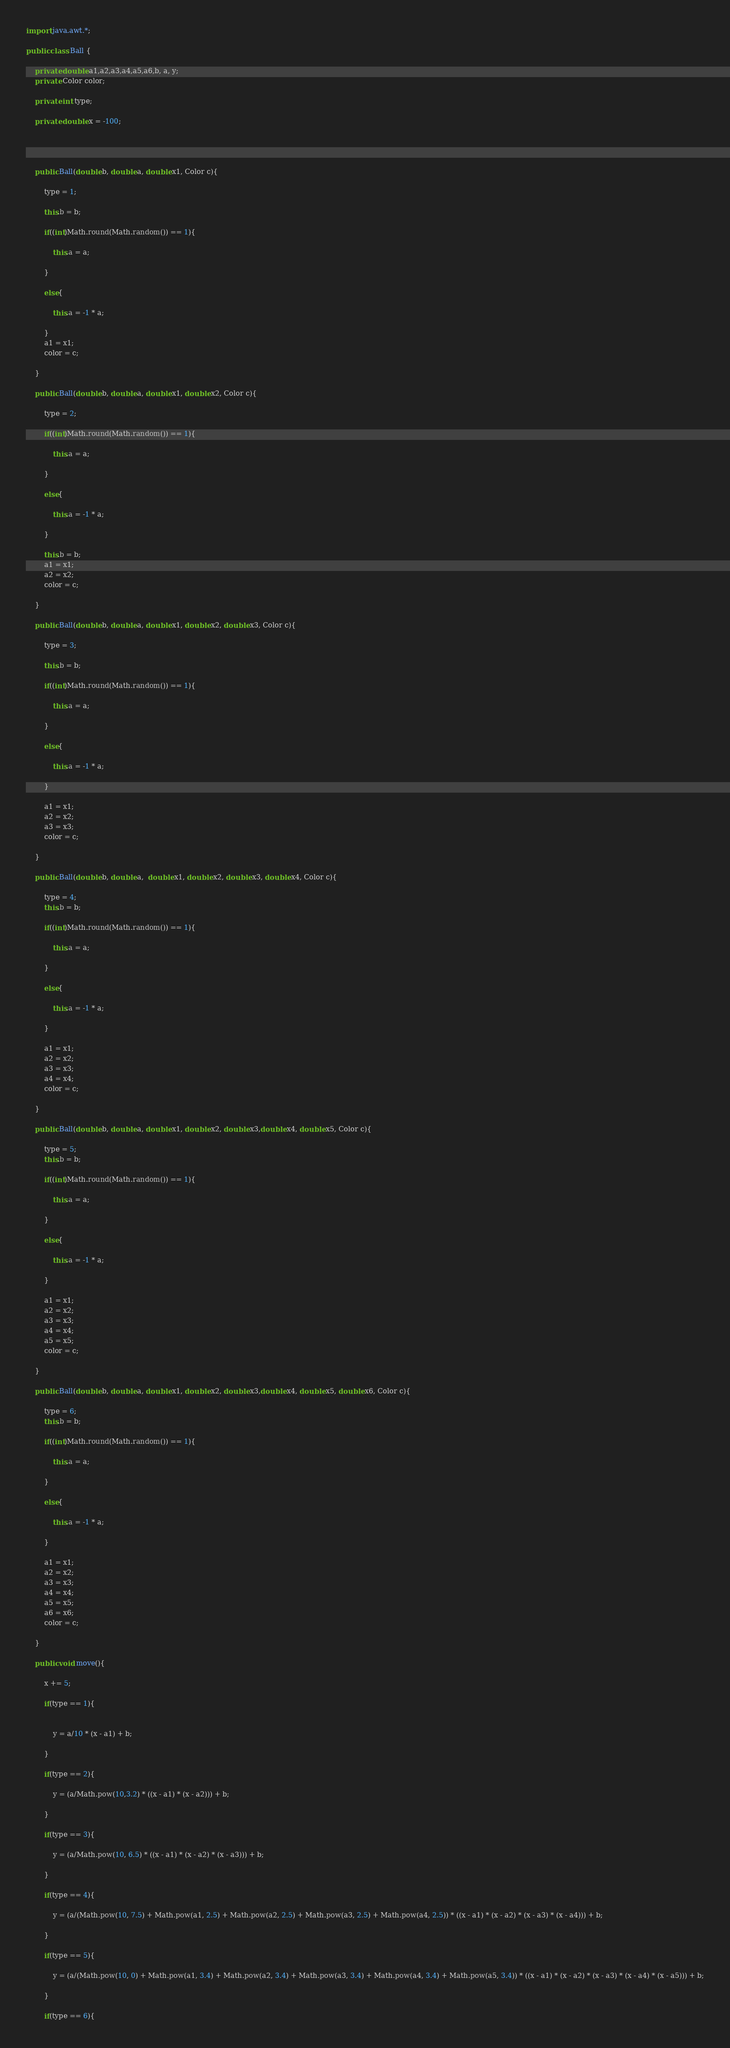<code> <loc_0><loc_0><loc_500><loc_500><_Java_>import java.awt.*;

public class Ball {

    private double a1,a2,a3,a4,a5,a6,b, a, y;
    private Color color;

    private int type;

    private double x = -100;




    public Ball(double b, double a, double x1, Color c){

        type = 1;

        this.b = b;

        if((int)Math.round(Math.random()) == 1){

            this.a = a;

        }

        else{

            this.a = -1 * a;

        }
        a1 = x1;
        color = c;

    }

    public Ball(double b, double a, double x1, double x2, Color c){

        type = 2;

        if((int)Math.round(Math.random()) == 1){

            this.a = a;

        }

        else{

            this.a = -1 * a;

        }

        this.b = b;
        a1 = x1;
        a2 = x2;
        color = c;

    }

    public Ball(double b, double a, double x1, double x2, double x3, Color c){

        type = 3;

        this.b = b;

        if((int)Math.round(Math.random()) == 1){

            this.a = a;

        }

        else{

            this.a = -1 * a;

        }

        a1 = x1;
        a2 = x2;
        a3 = x3;
        color = c;

    }

    public Ball(double b, double a,  double x1, double x2, double x3, double x4, Color c){

        type = 4;
        this.b = b;

        if((int)Math.round(Math.random()) == 1){

            this.a = a;

        }

        else{

            this.a = -1 * a;

        }

        a1 = x1;
        a2 = x2;
        a3 = x3;
        a4 = x4;
        color = c;

    }

    public Ball(double b, double a, double x1, double x2, double x3,double x4, double x5, Color c){

        type = 5;
        this.b = b;

        if((int)Math.round(Math.random()) == 1){

            this.a = a;

        }

        else{

            this.a = -1 * a;

        }

        a1 = x1;
        a2 = x2;
        a3 = x3;
        a4 = x4;
        a5 = x5;
        color = c;

    }

    public Ball(double b, double a, double x1, double x2, double x3,double x4, double x5, double x6, Color c){

        type = 6;
        this.b = b;

        if((int)Math.round(Math.random()) == 1){

            this.a = a;

        }

        else{

            this.a = -1 * a;

        }

        a1 = x1;
        a2 = x2;
        a3 = x3;
        a4 = x4;
        a5 = x5;
        a6 = x6;
        color = c;

    }

    public void move(){

        x += 5;

        if(type == 1){


            y = a/10 * (x - a1) + b;

        }

        if(type == 2){

            y = (a/Math.pow(10,3.2) * ((x - a1) * (x - a2))) + b;

        }

        if(type == 3){

            y = (a/Math.pow(10, 6.5) * ((x - a1) * (x - a2) * (x - a3))) + b;

        }

        if(type == 4){

            y = (a/(Math.pow(10, 7.5) + Math.pow(a1, 2.5) + Math.pow(a2, 2.5) + Math.pow(a3, 2.5) + Math.pow(a4, 2.5)) * ((x - a1) * (x - a2) * (x - a3) * (x - a4))) + b;

        }

        if(type == 5){

            y = (a/(Math.pow(10, 0) + Math.pow(a1, 3.4) + Math.pow(a2, 3.4) + Math.pow(a3, 3.4) + Math.pow(a4, 3.4) + Math.pow(a5, 3.4)) * ((x - a1) * (x - a2) * (x - a3) * (x - a4) * (x - a5))) + b;

        }

        if(type == 6){
</code> 